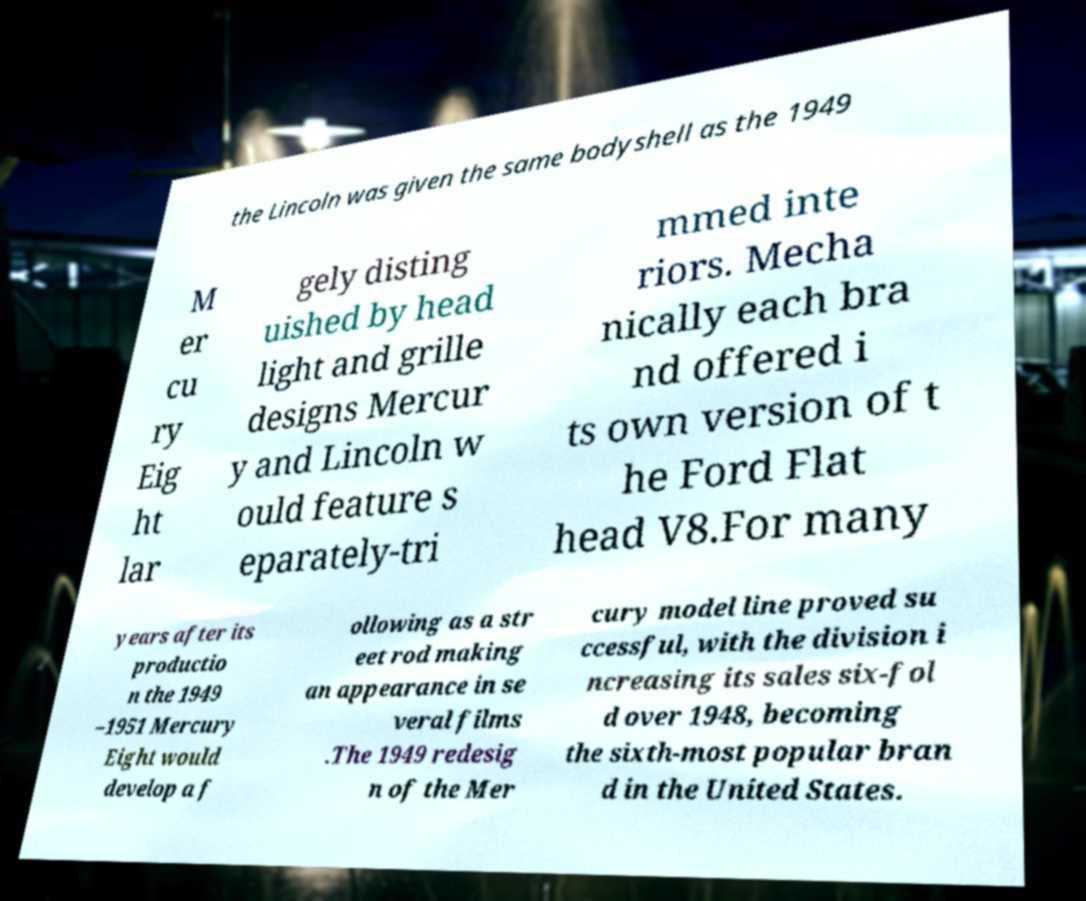I need the written content from this picture converted into text. Can you do that? the Lincoln was given the same bodyshell as the 1949 M er cu ry Eig ht lar gely disting uished by head light and grille designs Mercur y and Lincoln w ould feature s eparately-tri mmed inte riors. Mecha nically each bra nd offered i ts own version of t he Ford Flat head V8.For many years after its productio n the 1949 –1951 Mercury Eight would develop a f ollowing as a str eet rod making an appearance in se veral films .The 1949 redesig n of the Mer cury model line proved su ccessful, with the division i ncreasing its sales six-fol d over 1948, becoming the sixth-most popular bran d in the United States. 